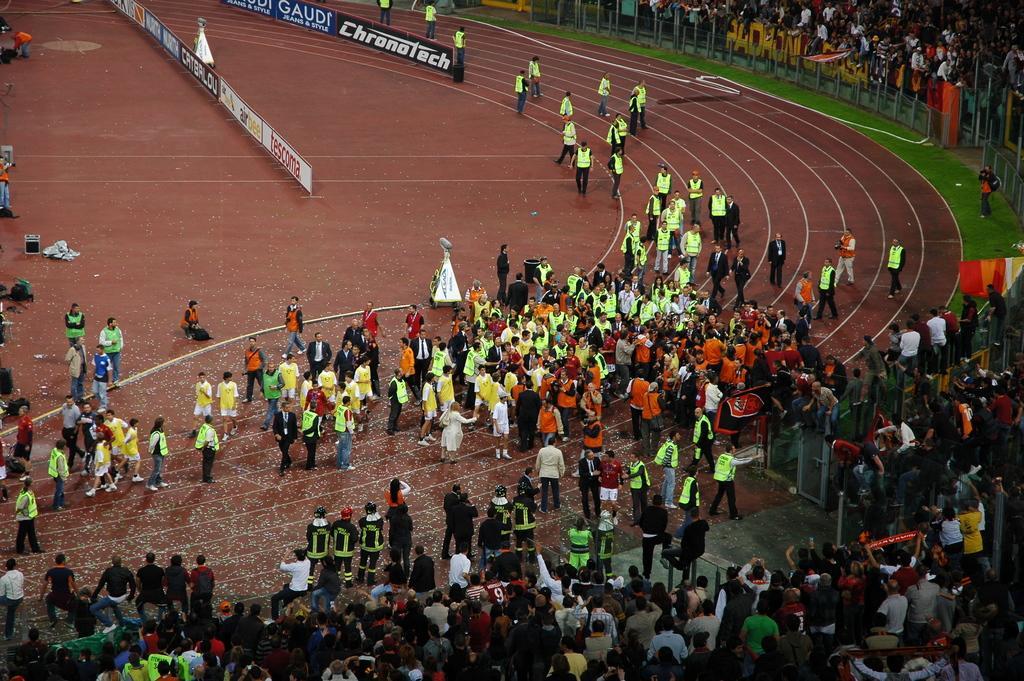Please provide a concise description of this image. In this image there is crowd. On the right there is a flag. In the background we can see boards. 